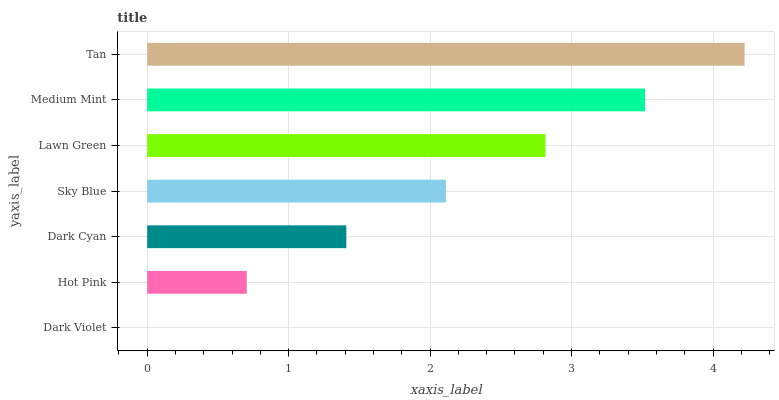Is Dark Violet the minimum?
Answer yes or no. Yes. Is Tan the maximum?
Answer yes or no. Yes. Is Hot Pink the minimum?
Answer yes or no. No. Is Hot Pink the maximum?
Answer yes or no. No. Is Hot Pink greater than Dark Violet?
Answer yes or no. Yes. Is Dark Violet less than Hot Pink?
Answer yes or no. Yes. Is Dark Violet greater than Hot Pink?
Answer yes or no. No. Is Hot Pink less than Dark Violet?
Answer yes or no. No. Is Sky Blue the high median?
Answer yes or no. Yes. Is Sky Blue the low median?
Answer yes or no. Yes. Is Tan the high median?
Answer yes or no. No. Is Medium Mint the low median?
Answer yes or no. No. 